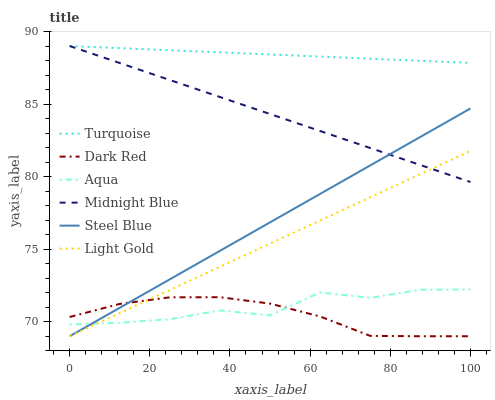Does Dark Red have the minimum area under the curve?
Answer yes or no. Yes. Does Turquoise have the maximum area under the curve?
Answer yes or no. Yes. Does Midnight Blue have the minimum area under the curve?
Answer yes or no. No. Does Midnight Blue have the maximum area under the curve?
Answer yes or no. No. Is Steel Blue the smoothest?
Answer yes or no. Yes. Is Aqua the roughest?
Answer yes or no. Yes. Is Midnight Blue the smoothest?
Answer yes or no. No. Is Midnight Blue the roughest?
Answer yes or no. No. Does Dark Red have the lowest value?
Answer yes or no. Yes. Does Midnight Blue have the lowest value?
Answer yes or no. No. Does Midnight Blue have the highest value?
Answer yes or no. Yes. Does Dark Red have the highest value?
Answer yes or no. No. Is Dark Red less than Midnight Blue?
Answer yes or no. Yes. Is Turquoise greater than Steel Blue?
Answer yes or no. Yes. Does Midnight Blue intersect Steel Blue?
Answer yes or no. Yes. Is Midnight Blue less than Steel Blue?
Answer yes or no. No. Is Midnight Blue greater than Steel Blue?
Answer yes or no. No. Does Dark Red intersect Midnight Blue?
Answer yes or no. No. 